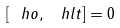<formula> <loc_0><loc_0><loc_500><loc_500>\left [ \ h o , \, \ h l t \right ] = 0</formula> 